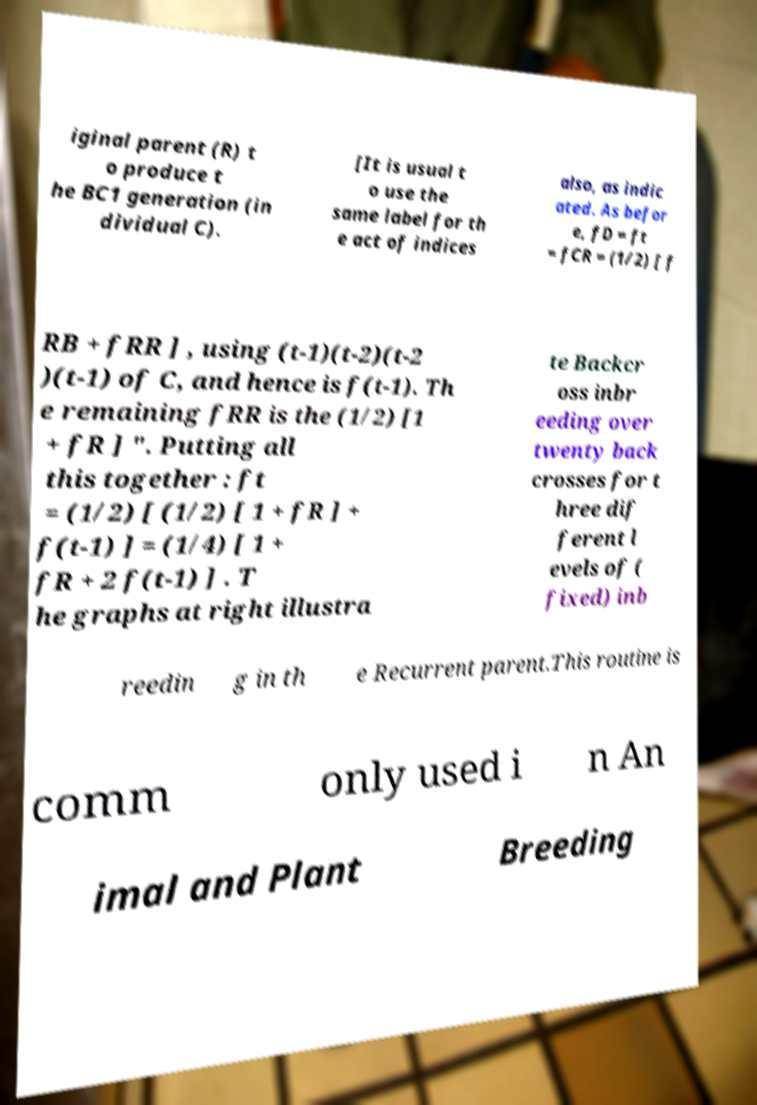For documentation purposes, I need the text within this image transcribed. Could you provide that? iginal parent (R) t o produce t he BC1 generation (in dividual C). [It is usual t o use the same label for th e act of indices also, as indic ated. As befor e, fD = ft = fCR = (1/2) [ f RB + fRR ] , using (t-1)(t-2)(t-2 )(t-1) of C, and hence is f(t-1). Th e remaining fRR is the (1/2) [1 + fR ] ". Putting all this together : ft = (1/2) [ (1/2) [ 1 + fR ] + f(t-1) ] = (1/4) [ 1 + fR + 2 f(t-1) ] . T he graphs at right illustra te Backcr oss inbr eeding over twenty back crosses for t hree dif ferent l evels of ( fixed) inb reedin g in th e Recurrent parent.This routine is comm only used i n An imal and Plant Breeding 